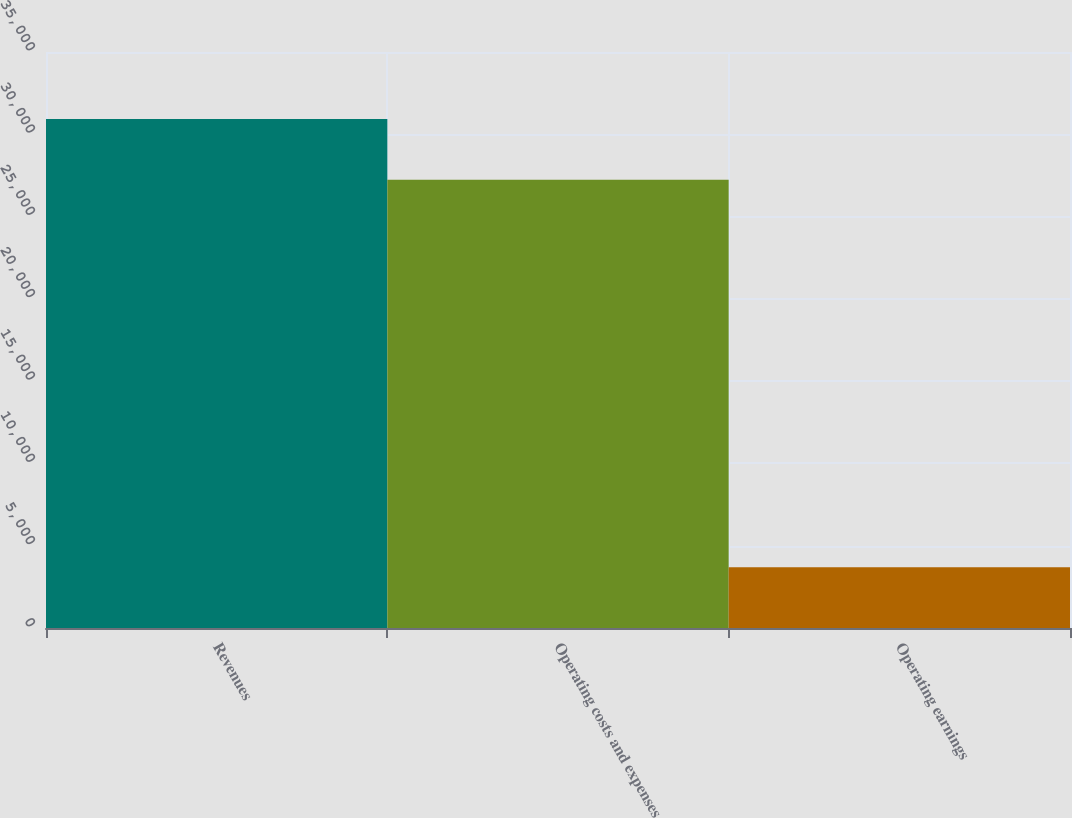<chart> <loc_0><loc_0><loc_500><loc_500><bar_chart><fcel>Revenues<fcel>Operating costs and expenses<fcel>Operating earnings<nl><fcel>30930<fcel>27241<fcel>3689<nl></chart> 